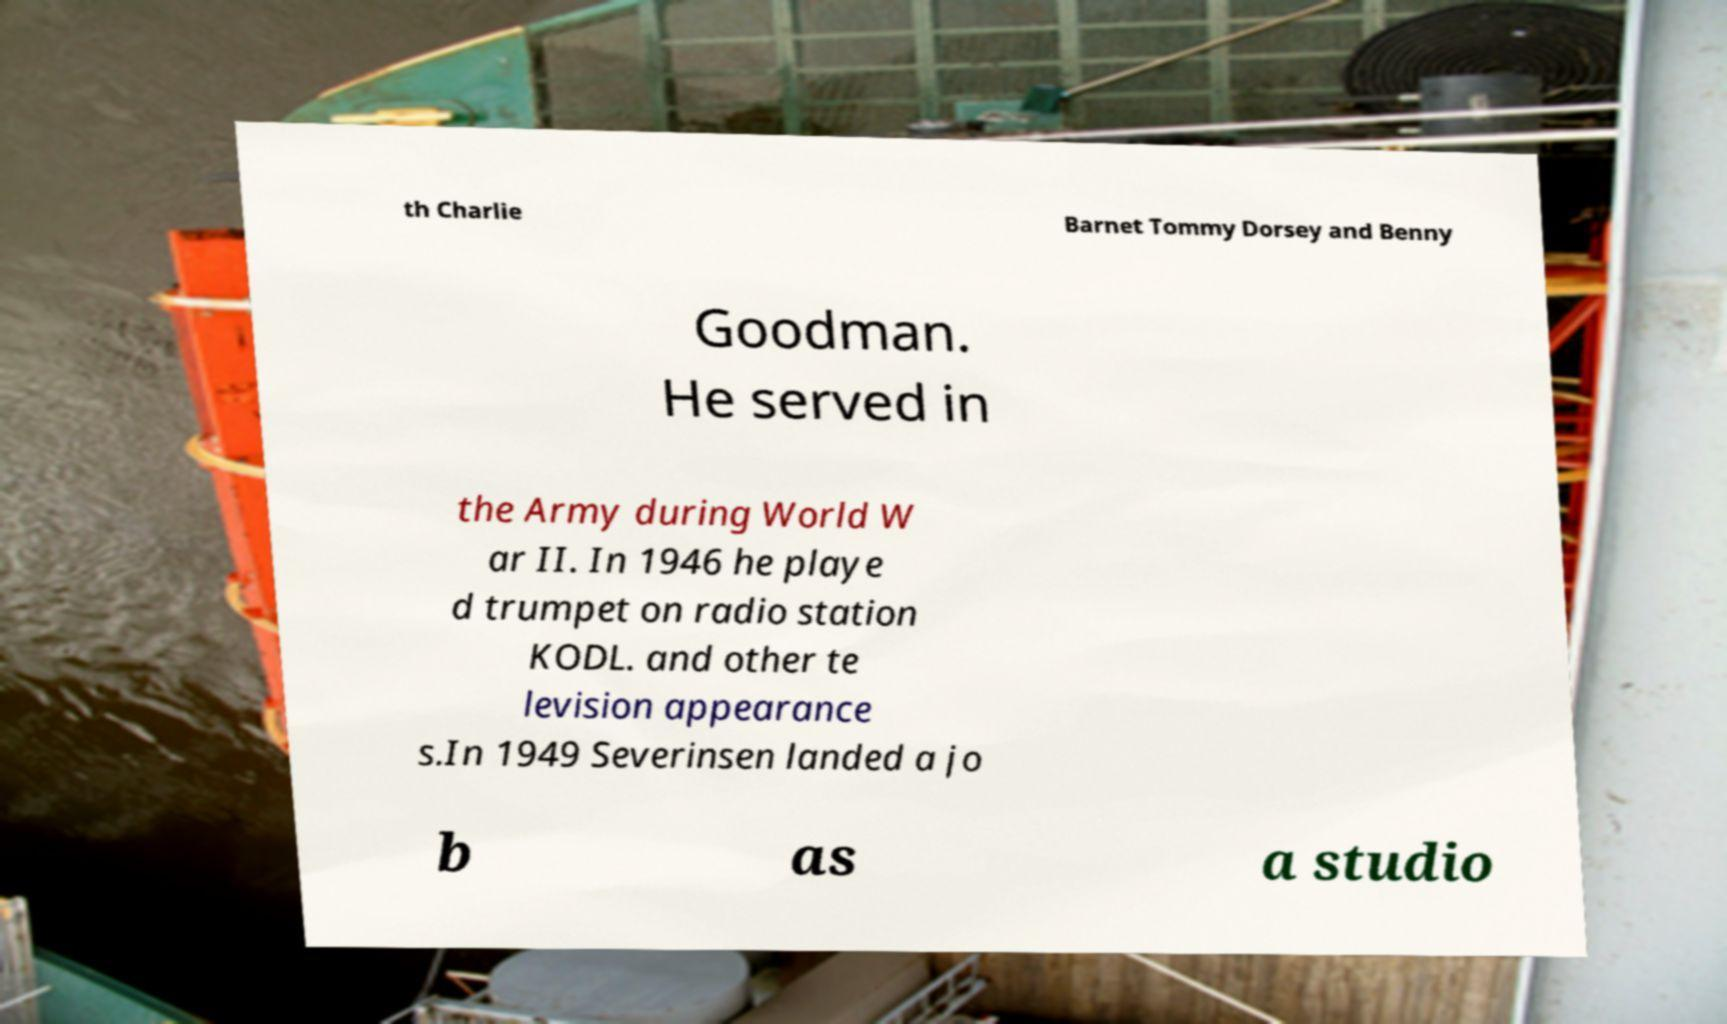For documentation purposes, I need the text within this image transcribed. Could you provide that? th Charlie Barnet Tommy Dorsey and Benny Goodman. He served in the Army during World W ar II. In 1946 he playe d trumpet on radio station KODL. and other te levision appearance s.In 1949 Severinsen landed a jo b as a studio 